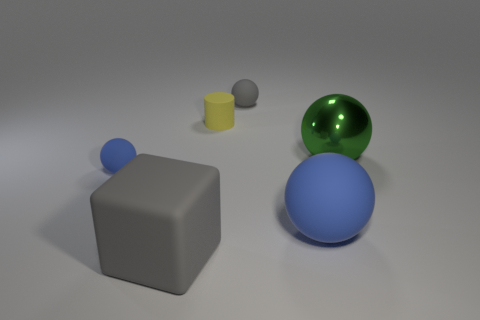What size is the rubber cube?
Make the answer very short. Large. Are there any other things that are made of the same material as the green ball?
Your answer should be compact. No. There is a tiny sphere left of the large gray thing on the left side of the big rubber ball; are there any gray matte balls that are left of it?
Ensure brevity in your answer.  No. How many small objects are purple cylinders or blue balls?
Give a very brief answer. 1. Is there anything else of the same color as the rubber cube?
Offer a very short reply. Yes. There is a blue rubber sphere that is left of the matte cylinder; is it the same size as the big block?
Offer a very short reply. No. What is the color of the matte object in front of the blue thing that is to the right of the gray rubber object in front of the large green ball?
Offer a terse response. Gray. The large block has what color?
Keep it short and to the point. Gray. Is the block the same color as the large metal thing?
Your answer should be compact. No. Are the gray object that is behind the tiny blue rubber thing and the small thing that is in front of the metal ball made of the same material?
Offer a terse response. Yes. 